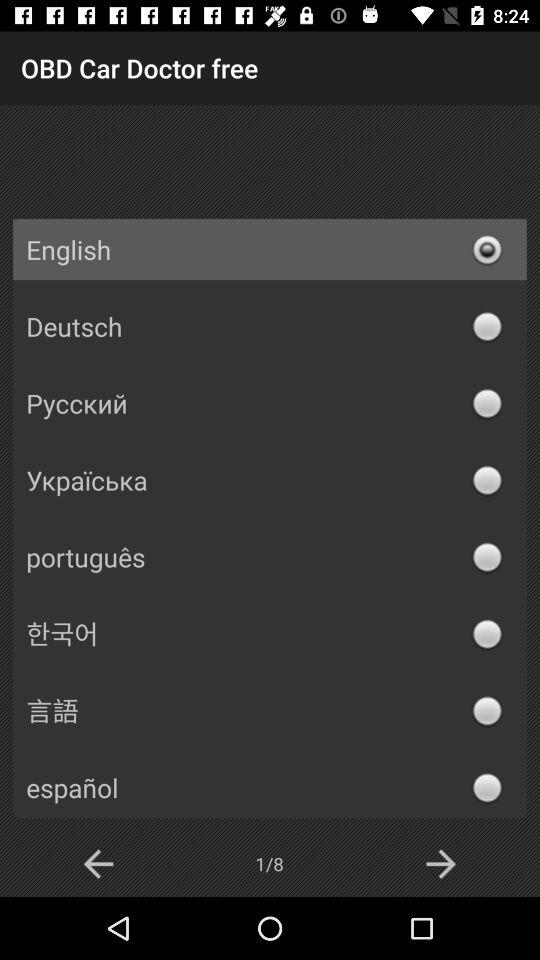How many pages in total are there? There are 8 pages in total. 